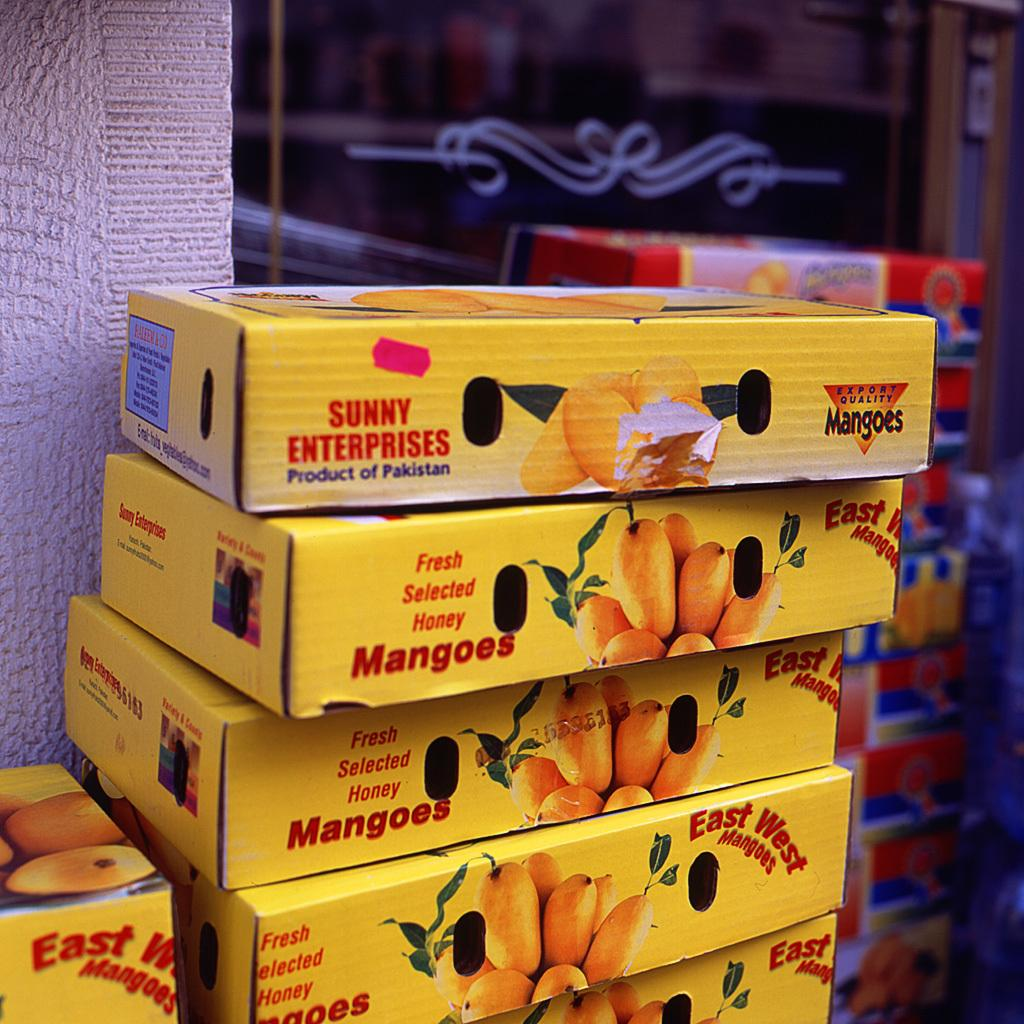What type of containers are visible in the image? There are printed cardboard cartons in the image. How are the cartons arranged in the image? The cartons are arranged in a row. What type of air can be seen coming out of the umbrella in the image? There is no umbrella present in the image, so it is not possible to determine what type of air might be coming out of it. 